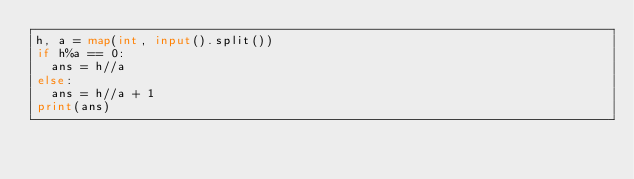<code> <loc_0><loc_0><loc_500><loc_500><_Python_>h, a = map(int, input().split())
if h%a == 0:
  ans = h//a
else:
  ans = h//a + 1
print(ans)
</code> 